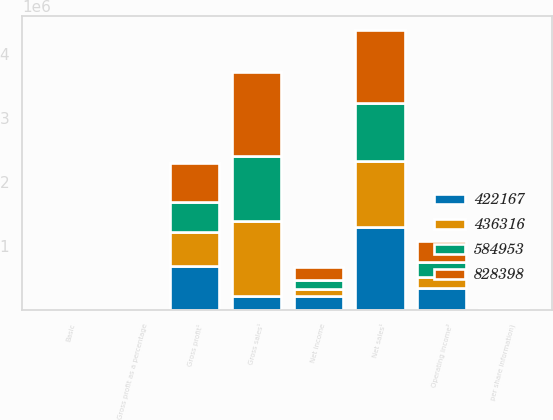<chart> <loc_0><loc_0><loc_500><loc_500><stacked_bar_chart><ecel><fcel>per share information)<fcel>Gross sales¹<fcel>Net sales¹<fcel>Gross profit¹<fcel>Gross profit as a percentage<fcel>Operating income²<fcel>Net income<fcel>Basic<nl><fcel>422167<fcel>2010<fcel>208716<fcel>1.30394e+06<fcel>680240<fcel>52.2<fcel>347814<fcel>212029<fcel>2.4<nl><fcel>828398<fcel>2009<fcel>1.30934e+06<fcel>1.1433e+06<fcel>612316<fcel>53.6<fcel>337309<fcel>208716<fcel>2.32<nl><fcel>436316<fcel>2008<fcel>1.18288e+06<fcel>1.03378e+06<fcel>538794<fcel>52.1<fcel>163591<fcel>108032<fcel>1.17<nl><fcel>584953<fcel>2007<fcel>1.0258e+06<fcel>904465<fcel>468013<fcel>51.7<fcel>230986<fcel>149406<fcel>1.64<nl></chart> 